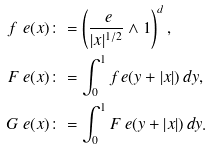Convert formula to latex. <formula><loc_0><loc_0><loc_500><loc_500>f _ { \ } e ( x ) & \colon = \left ( \frac { \ e } { | x | ^ { 1 / 2 } } \wedge 1 \right ) ^ { d } , \\ F _ { \ } e ( x ) & \colon = \int _ { 0 } ^ { 1 } f _ { \ } e ( y + | x | ) \, d y , \\ G _ { \ } e ( x ) & \colon = \int _ { 0 } ^ { 1 } F _ { \ } e ( y + | x | ) \, d y .</formula> 